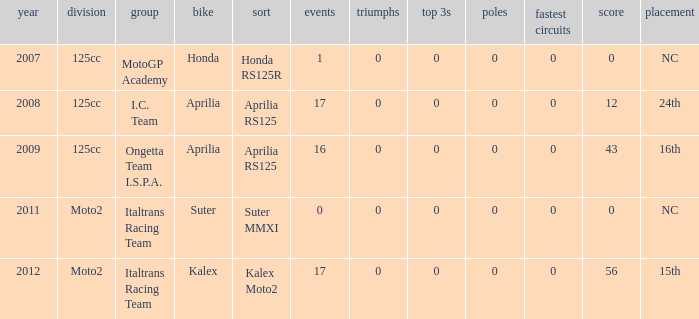How many fastest laps did I.C. Team have? 1.0. 